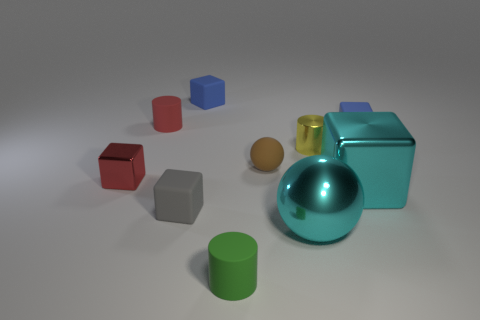Subtract all gray cubes. How many cubes are left? 4 Subtract all small metal blocks. How many blocks are left? 4 Subtract 2 cubes. How many cubes are left? 3 Subtract all brown blocks. Subtract all yellow spheres. How many blocks are left? 5 Subtract all cylinders. How many objects are left? 7 Subtract all large cyan objects. Subtract all small green things. How many objects are left? 7 Add 7 tiny gray matte cubes. How many tiny gray matte cubes are left? 8 Add 3 brown matte things. How many brown matte things exist? 4 Subtract 1 cyan spheres. How many objects are left? 9 